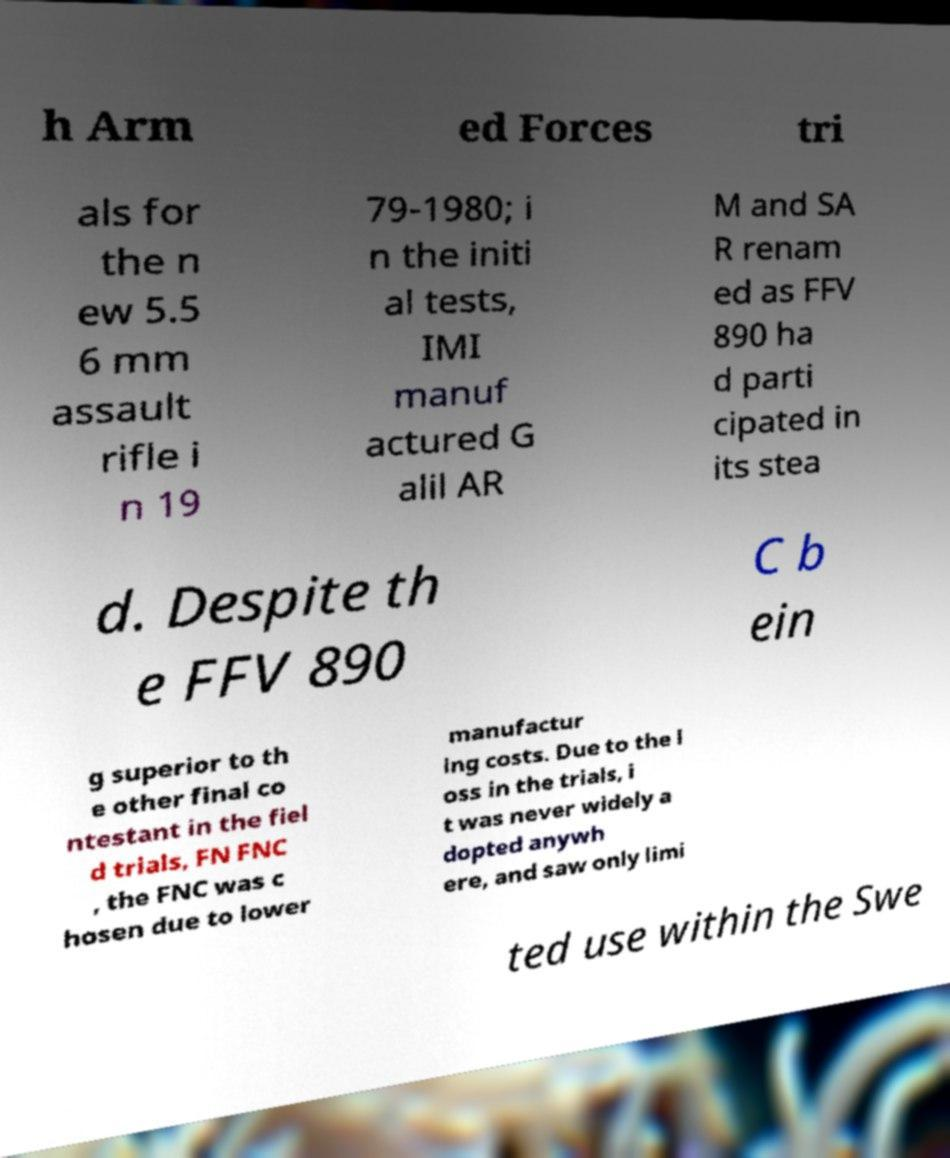Can you read and provide the text displayed in the image?This photo seems to have some interesting text. Can you extract and type it out for me? h Arm ed Forces tri als for the n ew 5.5 6 mm assault rifle i n 19 79-1980; i n the initi al tests, IMI manuf actured G alil AR M and SA R renam ed as FFV 890 ha d parti cipated in its stea d. Despite th e FFV 890 C b ein g superior to th e other final co ntestant in the fiel d trials, FN FNC , the FNC was c hosen due to lower manufactur ing costs. Due to the l oss in the trials, i t was never widely a dopted anywh ere, and saw only limi ted use within the Swe 